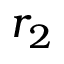Convert formula to latex. <formula><loc_0><loc_0><loc_500><loc_500>r _ { 2 }</formula> 